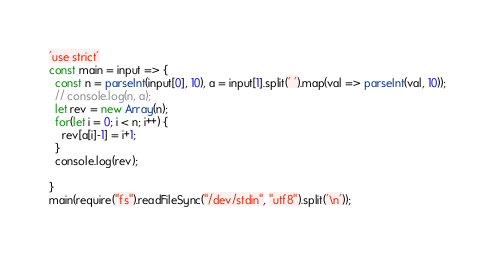<code> <loc_0><loc_0><loc_500><loc_500><_JavaScript_>'use strict'
const main = input => {
  const n = parseInt(input[0], 10), a = input[1].split(' ').map(val => parseInt(val, 10));
  // console.log(n, a);
  let rev = new Array(n);
  for(let i = 0; i < n; i++) {
    rev[a[i]-1] = i+1;
  }
  console.log(rev);
  
}
main(require("fs").readFileSync("/dev/stdin", "utf8").split('\n'));</code> 